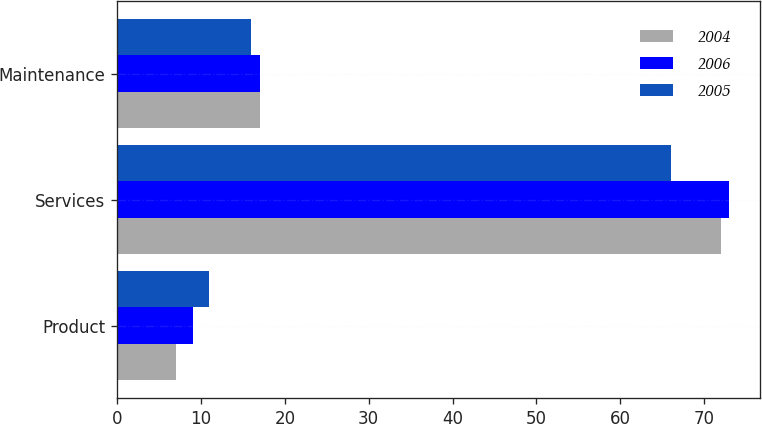Convert chart. <chart><loc_0><loc_0><loc_500><loc_500><stacked_bar_chart><ecel><fcel>Product<fcel>Services<fcel>Maintenance<nl><fcel>2004<fcel>7<fcel>72<fcel>17<nl><fcel>2006<fcel>9<fcel>73<fcel>17<nl><fcel>2005<fcel>11<fcel>66<fcel>16<nl></chart> 